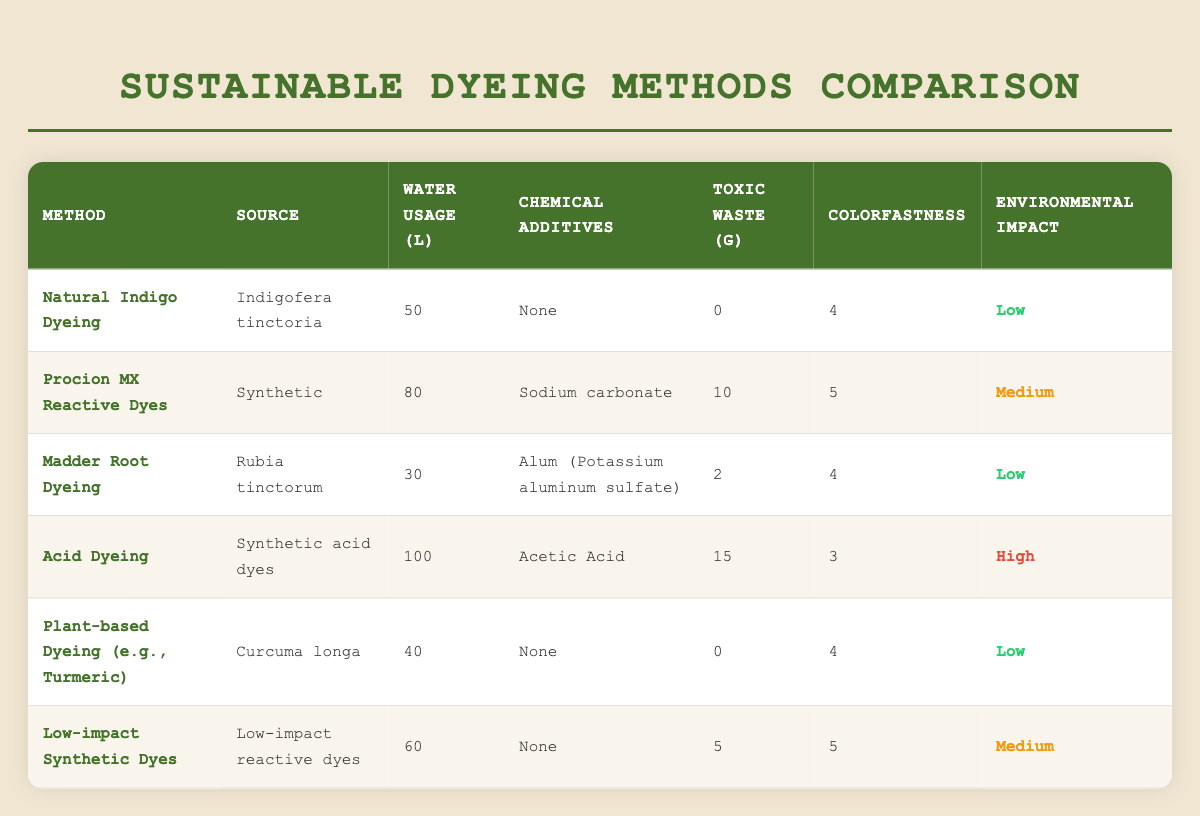What is the water usage for Acid Dyeing? The table lists the water usage for Acid Dyeing as 100 liters.
Answer: 100 liters Which dyeing method has the lowest toxic waste generated? Natural Indigo Dyeing and Plant-based Dyeing both have 0 grams of toxic waste generated.
Answer: Natural Indigo Dyeing and Plant-based Dyeing What is the colorfastness rating of Procion MX Reactive Dyes? According to the table, the colorfastness rating for Procion MX Reactive Dyes is 5.
Answer: 5 What is the average water usage across all dyeing methods? The water usage for each method is 50, 80, 30, 100, 40, and 60 liters. Summing these values gives 360 liters, and dividing by the number of methods (6) results in an average of 60 liters.
Answer: 60 liters Is there any dyeing method listed that does not use chemical additives? Yes, both Natural Indigo Dyeing and Plant-based Dyeing do not use any chemical additives according to the table.
Answer: Yes Which dyeing method has the highest environmental impact? The table indicates that Acid Dyeing has a high environmental impact, which is the highest level listed.
Answer: Acid Dyeing How many dyeing methods have a colorfastness rating of 4 or higher? The methods with a colorfastness rating of 4 or higher are: Natural Indigo Dyeing, Madder Root Dyeing, Plant-based Dyeing, Procion MX Reactive Dyes, and Low-impact Synthetic Dyes. That makes a total of 5 methods.
Answer: 5 methods What is the difference in water usage between Acid Dyeing and Madder Root Dyeing? Acid Dyeing uses 100 liters, while Madder Root Dyeing uses 30 liters. The difference is 100 - 30 = 70 liters.
Answer: 70 liters Which method generates more toxic waste, Low-impact Synthetic Dyes or Natural Indigo Dyeing? Low-impact Synthetic Dyes generate 5 grams of toxic waste while Natural Indigo Dyeing generates 0 grams. Therefore, Low-impact Synthetic Dyes generate more toxic waste.
Answer: Low-impact Synthetic Dyes 